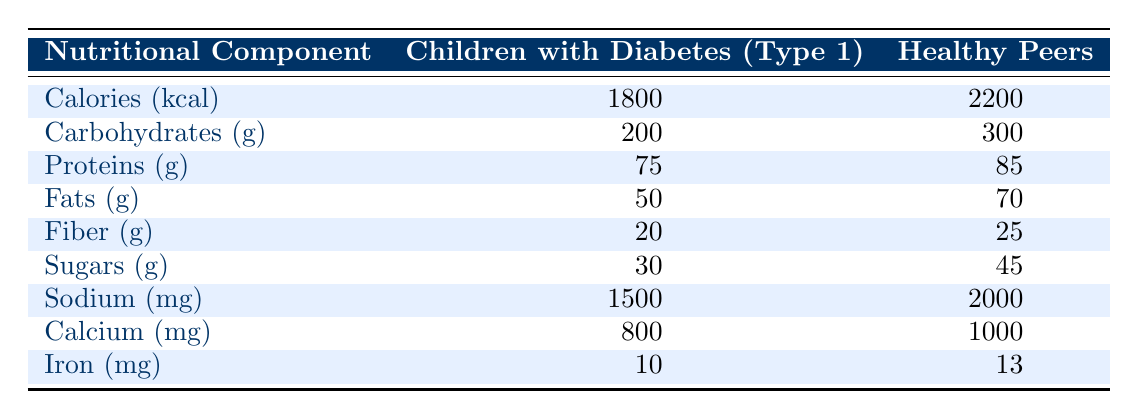What is the caloric intake of children with diabetes? According to the table, the caloric intake for children with diabetes is listed under the "Children with Diabetes" column for "Calories (kcal)," which shows a value of 1800.
Answer: 1800 How many grams of carbohydrates do healthy peers consume? The table indicates that the consumption of carbohydrates by healthy peers can be found in the "Healthy Peers" column under "Carbohydrates (g)," which shows a value of 300.
Answer: 300 What is the difference in protein intake between children with diabetes and healthy peers? To find the difference, subtract the protein intake of children with diabetes (75 grams) from that of healthy peers (85 grams): 85 - 75 = 10.
Answer: 10 Are children with diabetes consuming more sodium than healthy peers? The sodium intake for children with diabetes is 1500 mg, while for healthy peers it is 2000 mg. Since 1500 is less than 2000, the statement is false.
Answer: No What is the average intake of iron for both groups of children? First, we add the iron intake for both groups: 10 (children with diabetes) + 13 (healthy peers) = 23. Then, we divide this sum by 2 to get the average: 23 / 2 = 11.5.
Answer: 11.5 Which group consumes more fiber, and by how much? The fiber intake for children with diabetes is 20 grams, while for healthy peers it is 25 grams. Therefore, healthy peers consume more fiber: 25 - 20 = 5 grams more.
Answer: Healthy peers by 5 grams What minerals do both groups have in their diets, and who has more calcium? The table shows that both groups have calcium listed. Children with diabetes intake is 800 mg and healthy peers intake is 1000 mg. Healthy peers have more calcium because 1000 mg is greater than 800 mg.
Answer: Healthy peers have more calcium If we total the fat consumption for both groups, what is the result? The fat intake is 50 grams for children with diabetes and 70 grams for healthy peers. Summing these gives us: 50 + 70 = 120 grams of fat.
Answer: 120 grams How does the sugar intake of children with diabetes compare to that of healthy peers? Children with diabetes consume 30 grams of sugars, while healthy peers consume 45 grams. Since 30 is less than 45, this indicates that children with diabetes consume less sugar.
Answer: Less sugar for children with diabetes 